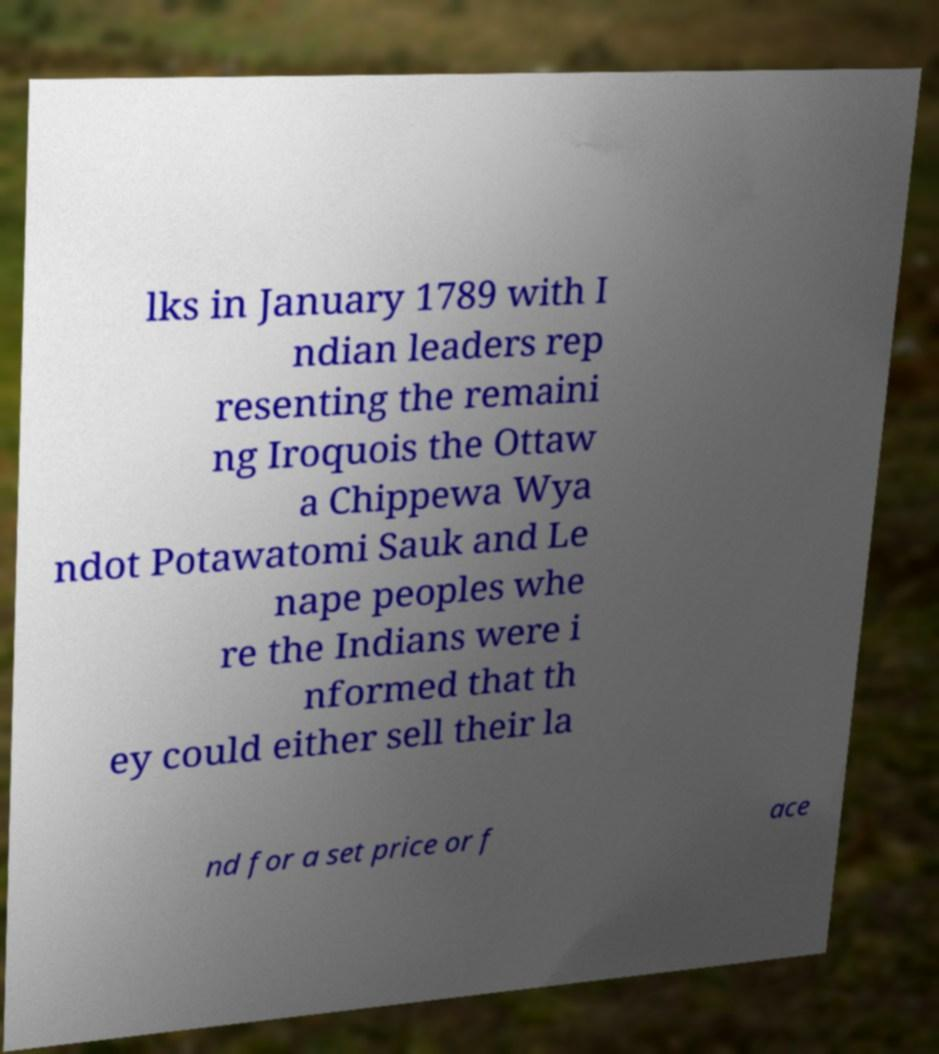Could you assist in decoding the text presented in this image and type it out clearly? lks in January 1789 with I ndian leaders rep resenting the remaini ng Iroquois the Ottaw a Chippewa Wya ndot Potawatomi Sauk and Le nape peoples whe re the Indians were i nformed that th ey could either sell their la nd for a set price or f ace 